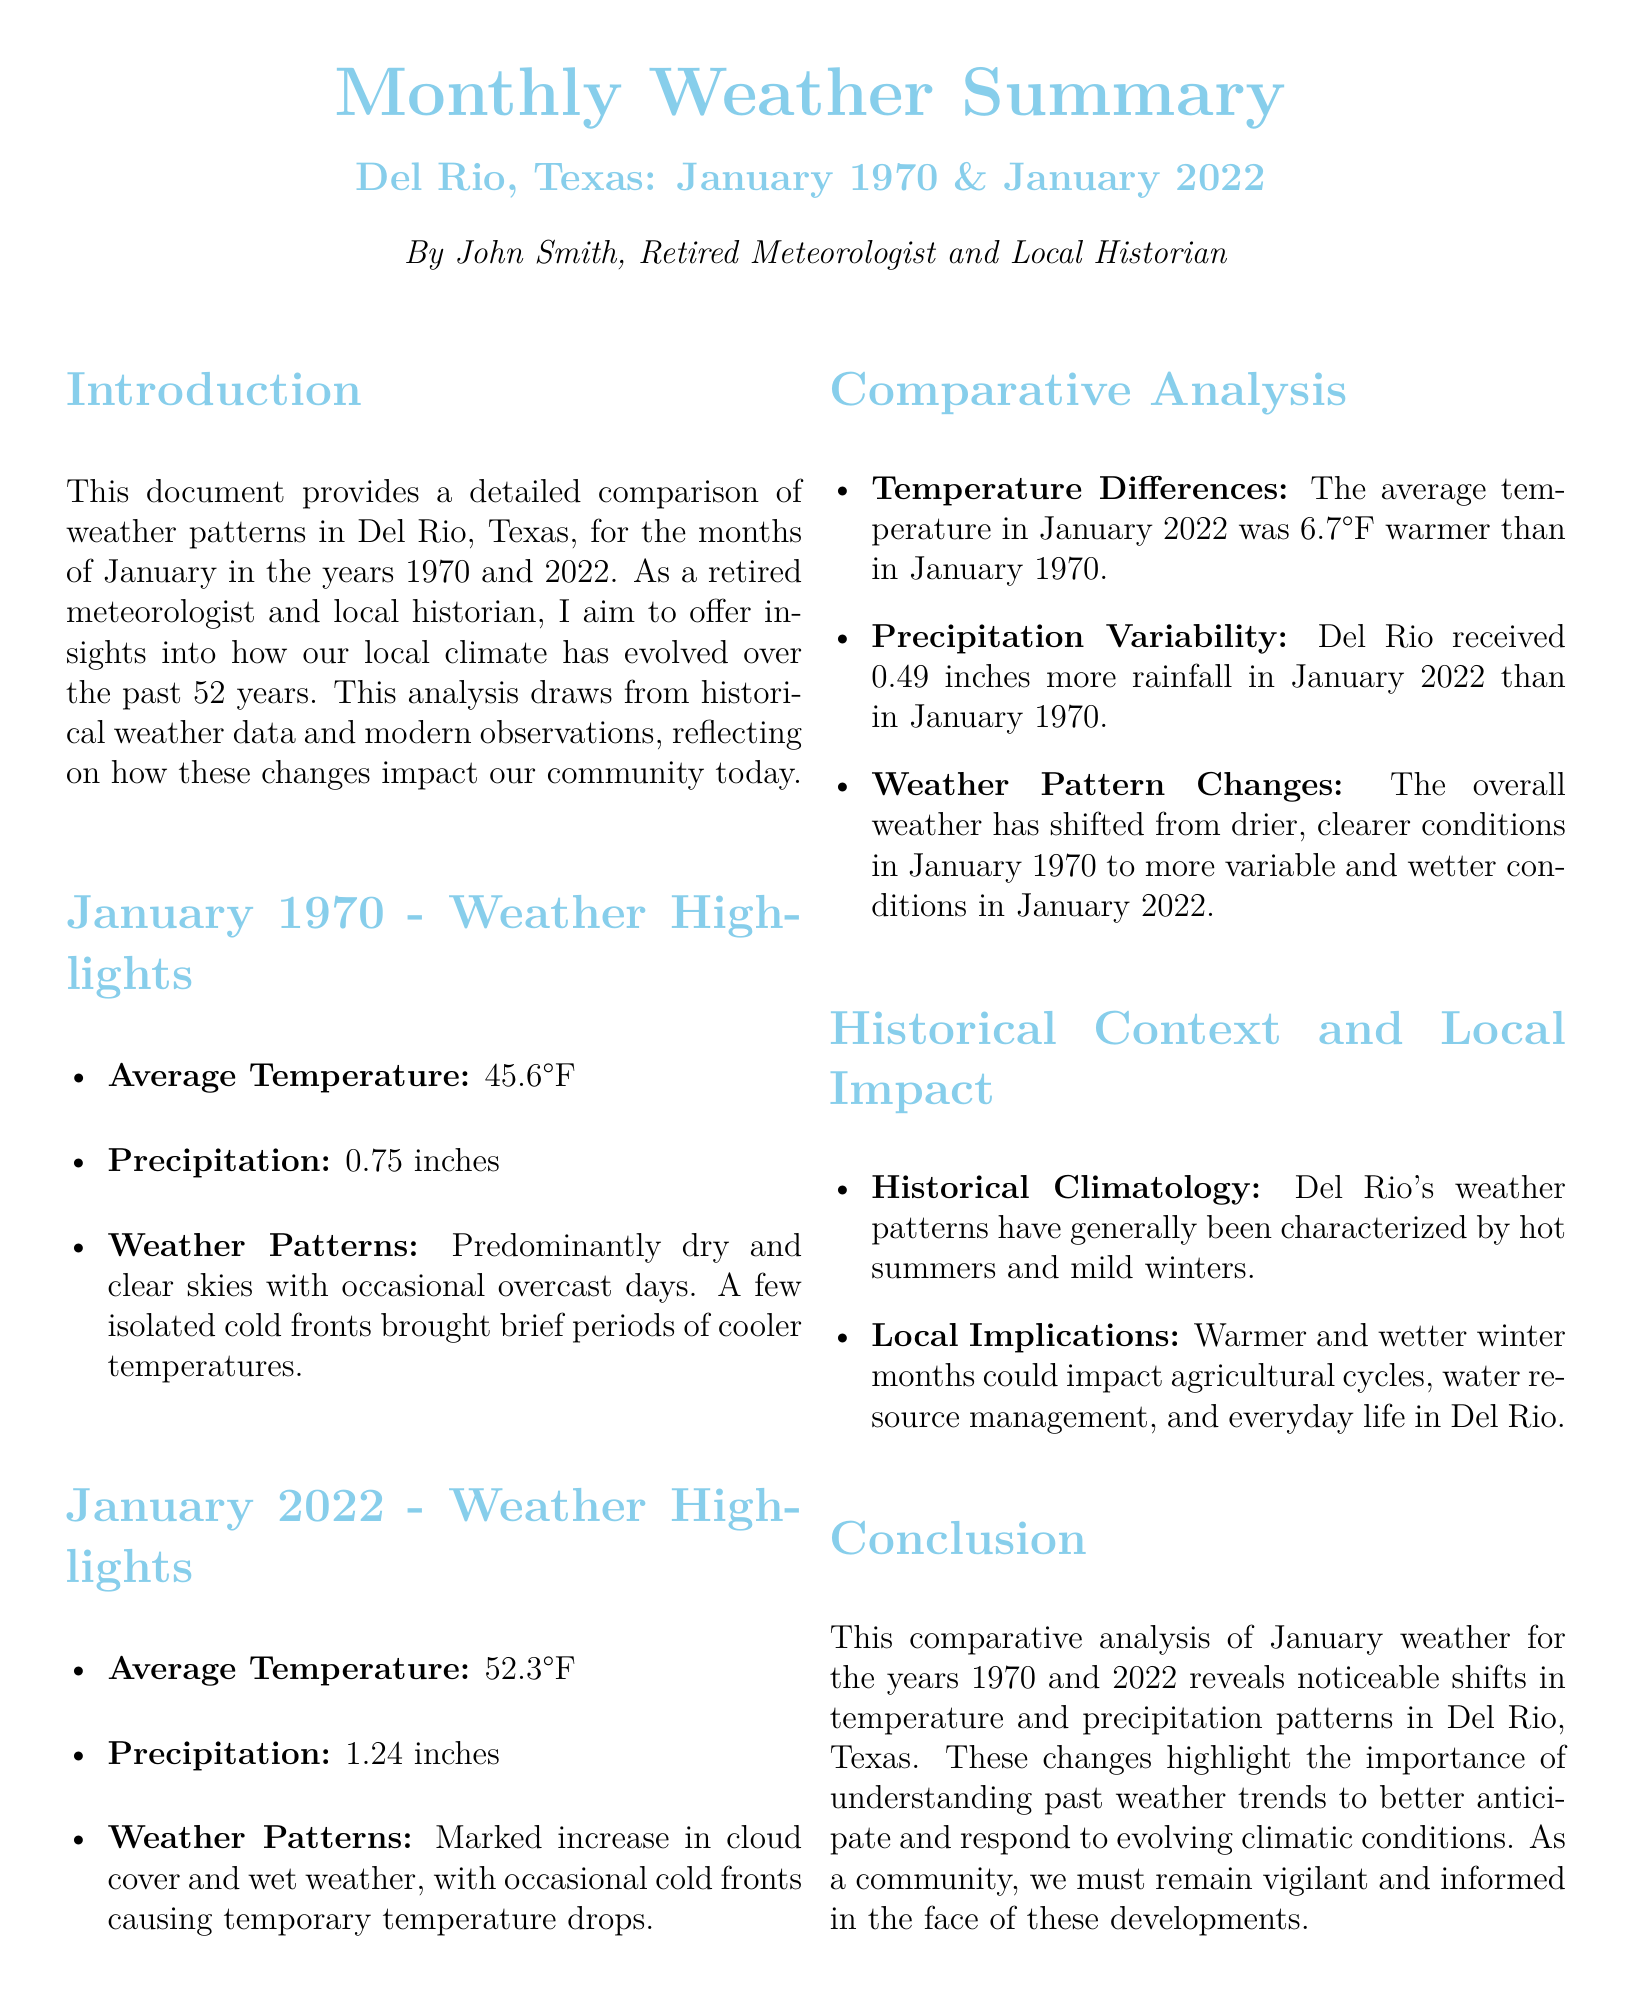What was the average temperature in January 1970? The document states that the average temperature in January 1970 was 45.6°F.
Answer: 45.6°F How much precipitation was recorded in January 2022? According to the summary, January 2022 received 1.24 inches of precipitation.
Answer: 1.24 inches What is the temperature difference between January 1970 and January 2022? The document indicates that January 2022 was 6.7°F warmer than January 1970.
Answer: 6.7°F What were the weather patterns like in January 1970? The summary describes the weather patterns in January 1970 as predominantly dry and clear skies.
Answer: Dry and clear skies What local implications of weather changes are mentioned? The document notes that warmer and wetter winter months could impact agricultural cycles.
Answer: Agricultural cycles Who authored the document? The introduction names John Smith as the author of the document.
Answer: John Smith What is the historical context provided in the document? The historical context indicates that Del Rio's weather patterns have generally been characterized by hot summers and mild winters.
Answer: Hot summers and mild winters How much more rainfall was recorded in January 2022 compared to January 1970? The text highlights that Del Rio received 0.49 inches more rainfall in January 2022 than in January 1970.
Answer: 0.49 inches 